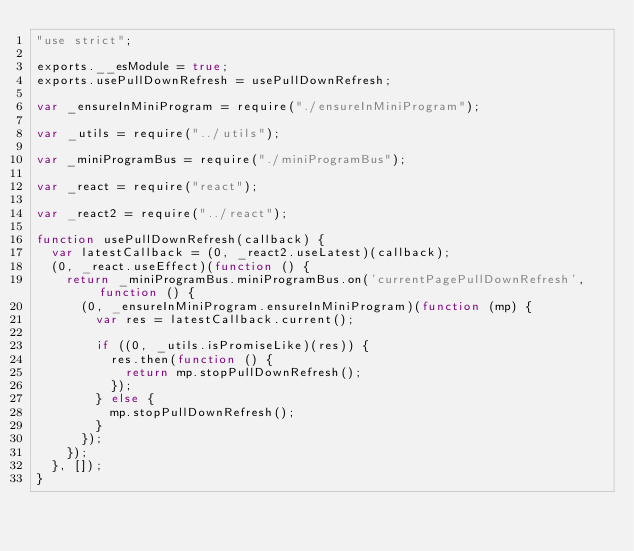Convert code to text. <code><loc_0><loc_0><loc_500><loc_500><_JavaScript_>"use strict";

exports.__esModule = true;
exports.usePullDownRefresh = usePullDownRefresh;

var _ensureInMiniProgram = require("./ensureInMiniProgram");

var _utils = require("../utils");

var _miniProgramBus = require("./miniProgramBus");

var _react = require("react");

var _react2 = require("../react");

function usePullDownRefresh(callback) {
  var latestCallback = (0, _react2.useLatest)(callback);
  (0, _react.useEffect)(function () {
    return _miniProgramBus.miniProgramBus.on('currentPagePullDownRefresh', function () {
      (0, _ensureInMiniProgram.ensureInMiniProgram)(function (mp) {
        var res = latestCallback.current();

        if ((0, _utils.isPromiseLike)(res)) {
          res.then(function () {
            return mp.stopPullDownRefresh();
          });
        } else {
          mp.stopPullDownRefresh();
        }
      });
    });
  }, []);
}</code> 